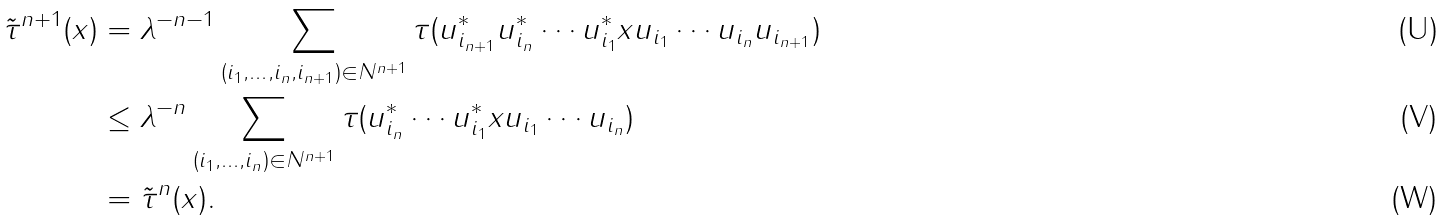Convert formula to latex. <formula><loc_0><loc_0><loc_500><loc_500>\tilde { \tau } ^ { n + 1 } ( x ) & = \lambda ^ { - n - 1 } \sum _ { ( i _ { 1 } , \dots , i _ { n } , i _ { n + 1 } ) \in { { N } ^ { n + 1 } } } \tau ( u _ { i _ { n + 1 } } ^ { * } u _ { i _ { n } } ^ { * } \cdots u _ { i _ { 1 } } ^ { * } x u _ { i _ { 1 } } \cdots u _ { i _ { n } } u _ { i _ { n + 1 } } ) \\ & \leq \lambda ^ { - n } \sum _ { ( i _ { 1 } , \dots , i _ { n } ) \in { { N } ^ { n + 1 } } } \tau ( u _ { i _ { n } } ^ { * } \cdots u _ { i _ { 1 } } ^ { * } x u _ { i _ { 1 } } \cdots u _ { i _ { n } } ) \\ & = \tilde { \tau } ^ { n } ( x ) .</formula> 